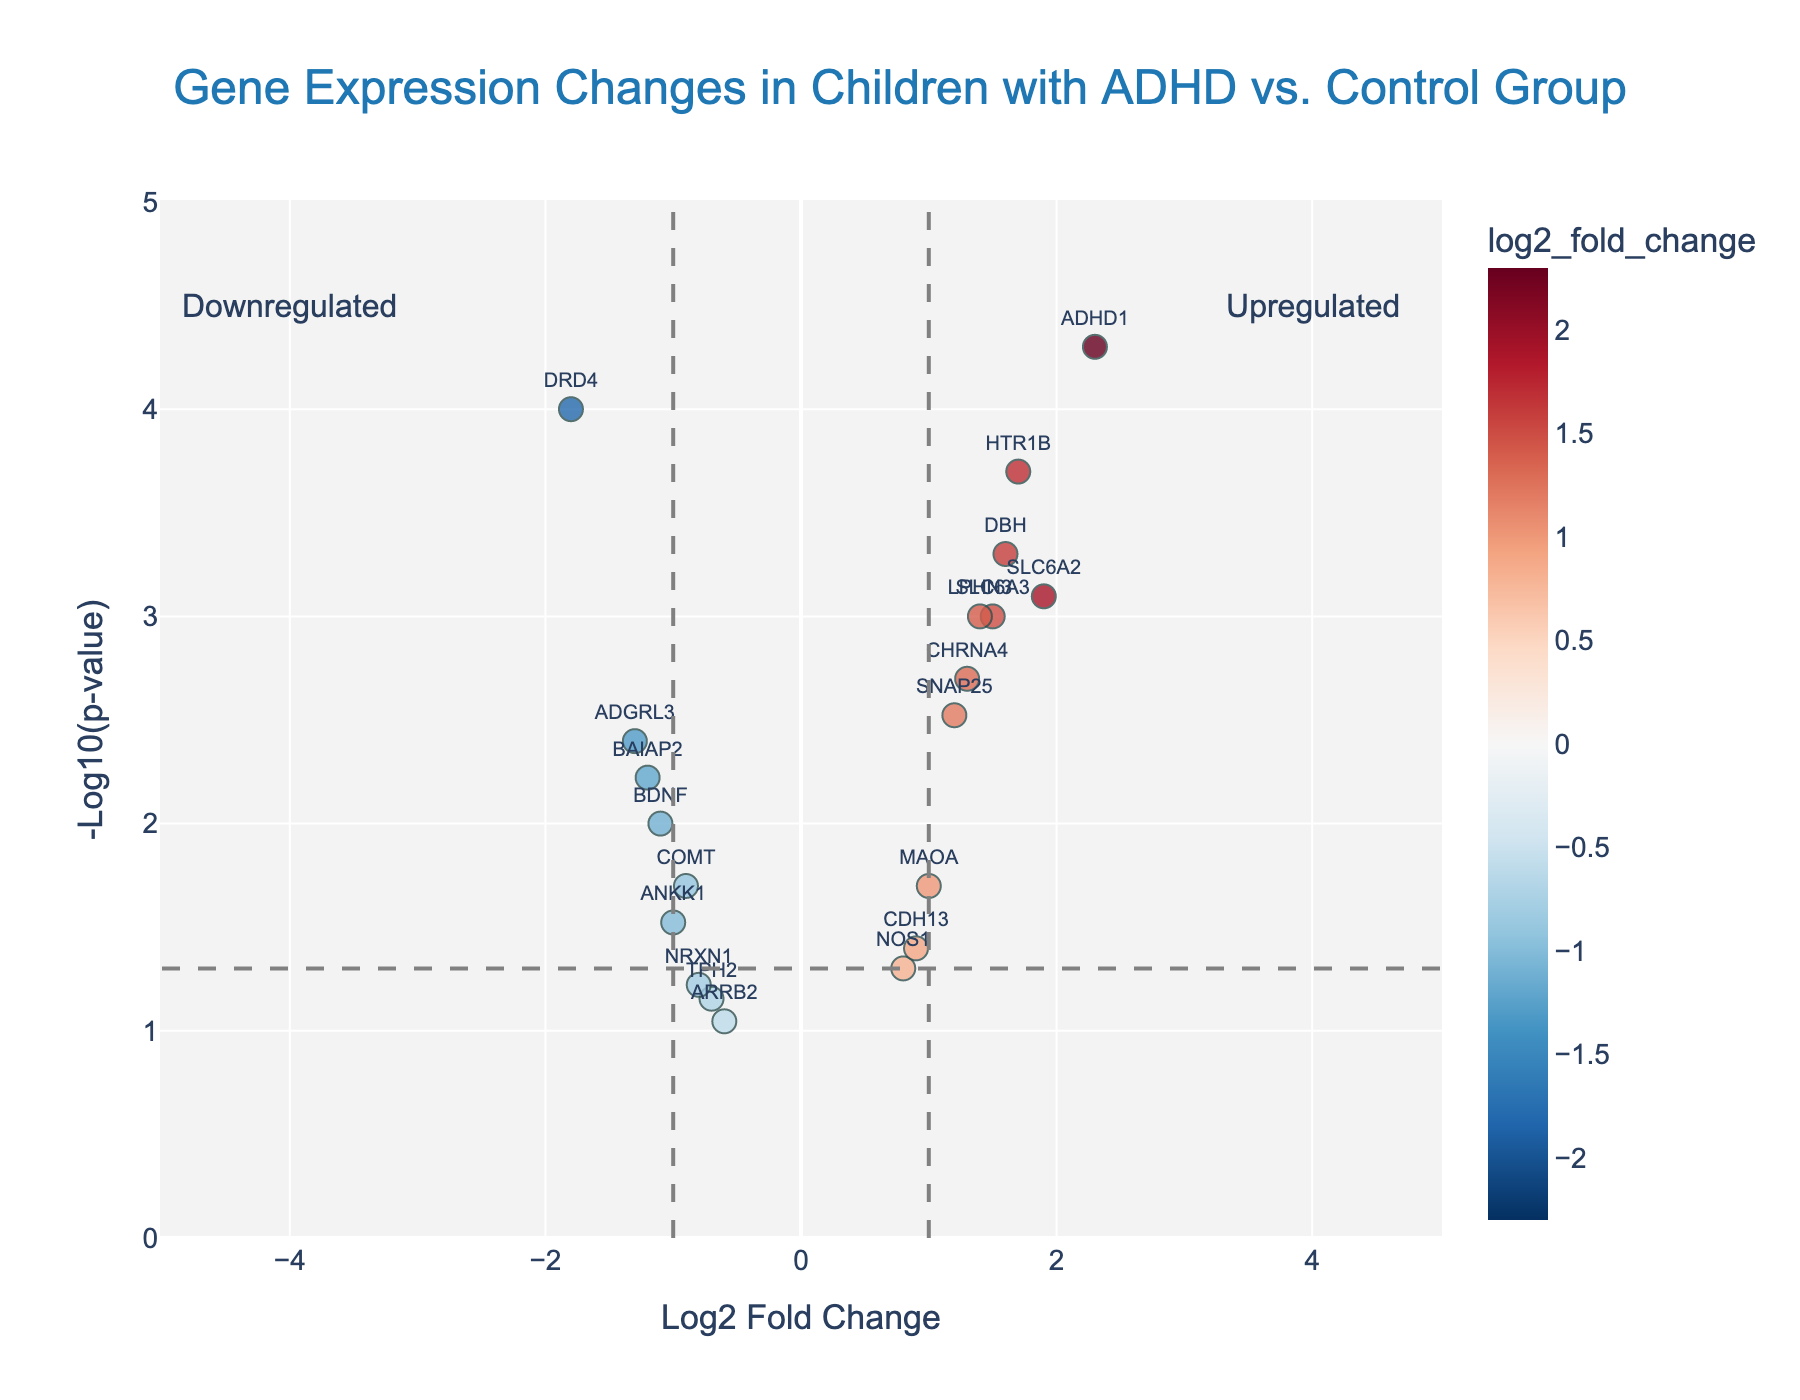What is the title of the volcano plot? Look at the top of the figure, where the title should be prominently displayed. The title provides a brief description of what the plot represents. In this case, it should be "Gene Expression Changes in Children with ADHD vs. Control Group".
Answer: Gene Expression Changes in Children with ADHD vs. Control Group What does the x-axis represent in the plot? The x-axis is labeled, and it shows the "Log2 Fold Change." This represents the logarithmic scale of changes in gene expression levels between children with ADHD and the control group.
Answer: Log2 Fold Change How many genes have a Log2 Fold Change greater than 1 and a p-value less than 0.05? Look for data points to the right of the vertical line at 1 on the x-axis and above the horizontal threshold line for -log10(p-value) = 1.3, which corresponds to a p-value of 0.05. The colored points in this region will indicate the genes that meet the criteria.
Answer: 6 genes Which gene has the most significant p-value in terms of being downregulated in children with ADHD? Identify the point with the lowest p-value (highest -log10(p-value) value) among the genes that are on the left side (negative Log2 Fold Change) of the plot. The gene name is displayed near the point.
Answer: DRD4 Are there any genes that are not significantly different in expression between the ADHD group and the control group? Points that fall below the horizontal threshold line (-log10(p-value) = 1.3 for p-value = 0.05) are not significantly different. They do not show clear differentiation based on the p-value criterion.
Answer: Yes Which gene shows the greatest fold change in expression in children with ADHD compared to the control group? This can be found by looking for the data point with the highest absolute value on the x-axis (Log2 Fold Change), regardless of the direction (positive or negative).
Answer: ADHD1 How is the gene SLC6A3 represented in the plot? Find the gene SLC6A3 by its label; check its position on the x-axis for Log2 Fold Change and the y-axis for -log10(p-value). This will tell us its level of expression change and its statistical significance.
Answer: Log2 Fold Change is 1.5 and p-value is 0.001 Compare the Log2 Fold Change of the genes SNAP25 and NOS1. Which one is higher? Look at the horizontal positions of SNAP25 and NOS1 in the plot. The gene further to the right has a higher Log2 Fold Change.
Answer: SNAP25 What does the color of the points indicate in the plot? The color scale represents the Log2 Fold Change, with different colors corresponding to different fold change values. The actual colors would range from shades of red to blue, typically indicating the extent and direction of expression changes.
Answer: Log2 Fold Change 